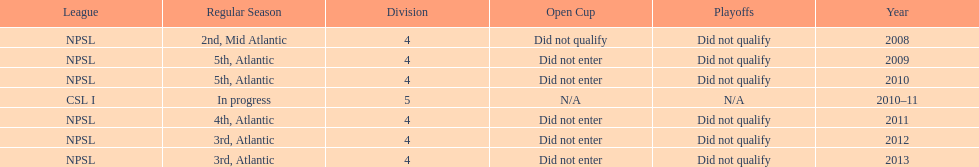What was the last year they came in 3rd place 2013. 